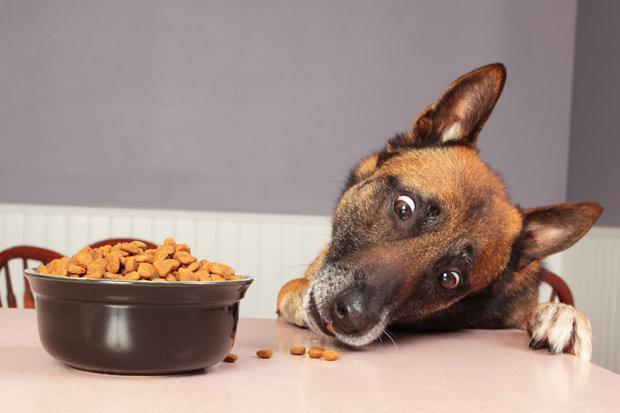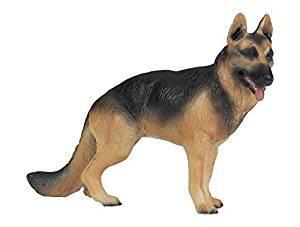The first image is the image on the left, the second image is the image on the right. Evaluate the accuracy of this statement regarding the images: "One dog is eating and has its head near a round bowl of food, and the other dog figure is standing on all fours.". Is it true? Answer yes or no. Yes. 